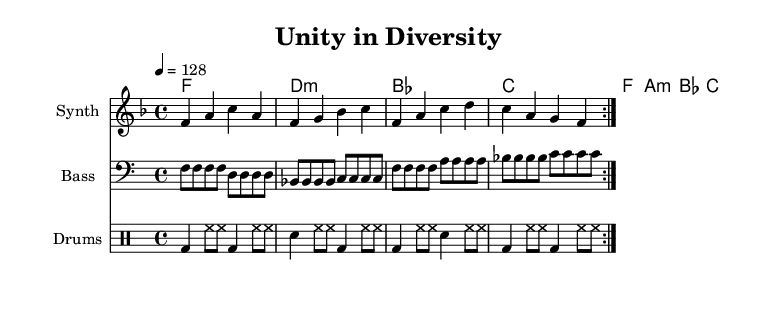What is the key signature of this music? The key signature is F major, which has one flat (B flat). This can be identified by looking at the beginning of the music sheet where the key signature is indicated.
Answer: F major What is the time signature of this music? The time signature is 4/4, which can be found at the beginning of the score. This indicates that there are four beats in each measure and the quarter note gets one beat.
Answer: 4/4 What is the tempo marking for this piece? The tempo marking is 128, specified within the instructions for tempo in beats per minute. It indicates how fast the piece should be played.
Answer: 128 How many measures are in the melody? The melody contains four measures, which can be counted by looking at the bar lines that separate the music into equal sections.
Answer: 4 What type of drum pattern is indicated? The drum pattern consists of a typical four-on-the-floor rhythm, where the bass drum is played on every beat, common in house music. This can be seen in the repeated patterns of the drum staff.
Answer: Four-on-the-floor What is the first chord of the harmony section? The first chord is F major, which is noted at the beginning of the harmony section. This can be confirmed by identifying the chord symbol at the start of the chord mode notation.
Answer: F What is the instrument used for the melody? The instrument used for the melody is a synth, as indicated in the staff name associated with the melodic line.
Answer: Synth 